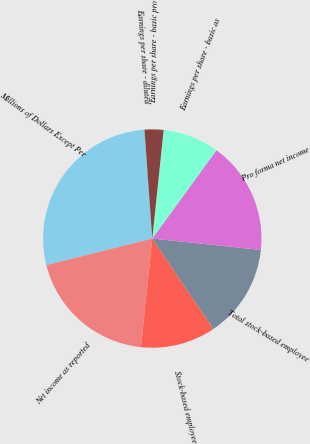<chart> <loc_0><loc_0><loc_500><loc_500><pie_chart><fcel>Millions of Dollars Except Per<fcel>Net income as reported<fcel>Stock-based employee<fcel>Total stock-based employee<fcel>Pro forma net income<fcel>Earnings per share - basic as<fcel>Earnings per share - basic pro<fcel>Earnings per share - diluted<nl><fcel>27.74%<fcel>19.43%<fcel>11.11%<fcel>13.89%<fcel>16.66%<fcel>8.34%<fcel>2.8%<fcel>0.03%<nl></chart> 